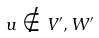<formula> <loc_0><loc_0><loc_500><loc_500>u \notin V ^ { \prime } , W ^ { \prime }</formula> 